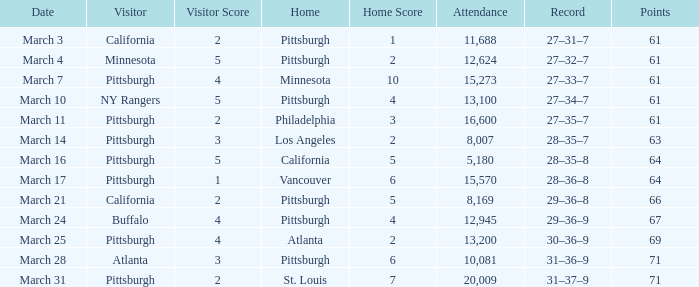What is the Score of the game with a Record of 31–37–9? 2–7. Could you help me parse every detail presented in this table? {'header': ['Date', 'Visitor', 'Visitor Score', 'Home', 'Home Score', 'Attendance', 'Record', 'Points'], 'rows': [['March 3', 'California', '2', 'Pittsburgh', '1', '11,688', '27–31–7', '61'], ['March 4', 'Minnesota', '5', 'Pittsburgh', '2', '12,624', '27–32–7', '61'], ['March 7', 'Pittsburgh', '4', 'Minnesota', '10', '15,273', '27–33–7', '61'], ['March 10', 'NY Rangers', '5', 'Pittsburgh', '4', '13,100', '27–34–7', '61'], ['March 11', 'Pittsburgh', '2', 'Philadelphia', '3', '16,600', '27–35–7', '61'], ['March 14', 'Pittsburgh', '3', 'Los Angeles', '2', '8,007', '28–35–7', '63'], ['March 16', 'Pittsburgh', '5', 'California', '5', '5,180', '28–35–8', '64'], ['March 17', 'Pittsburgh', '1', 'Vancouver', '6', '15,570', '28–36–8', '64'], ['March 21', 'California', '2', 'Pittsburgh', '5', '8,169', '29–36–8', '66'], ['March 24', 'Buffalo', '4', 'Pittsburgh', '4', '12,945', '29–36–9', '67'], ['March 25', 'Pittsburgh', '4', 'Atlanta', '2', '13,200', '30–36–9', '69'], ['March 28', 'Atlanta', '3', 'Pittsburgh', '6', '10,081', '31–36–9', '71'], ['March 31', 'Pittsburgh', '2', 'St. Louis', '7', '20,009', '31–37–9', '71']]} 